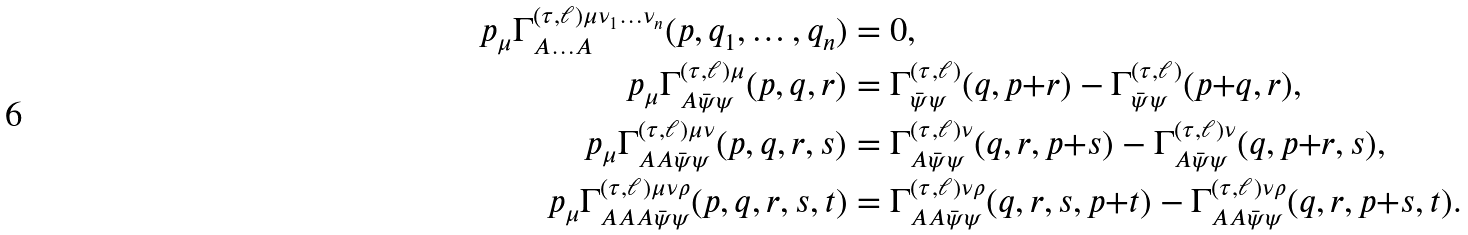Convert formula to latex. <formula><loc_0><loc_0><loc_500><loc_500>p _ { \mu } \Gamma ^ { ( \tau , \ell ) \mu \nu _ { 1 } \dots \nu _ { n } } _ { A \dots A } ( p , q _ { 1 } , \dots , q _ { n } ) & = 0 , \\ p _ { \mu } \Gamma ^ { ( \tau , \ell ) \mu } _ { A \bar { \psi } \psi } ( p , q , r ) & = \Gamma ^ { ( \tau , \ell ) } _ { \bar { \psi } \psi } ( q , p { + } r ) - \Gamma ^ { ( \tau , \ell ) } _ { \bar { \psi } \psi } ( p { + } q , r ) , \\ p _ { \mu } \Gamma ^ { ( \tau , \ell ) \mu \nu } _ { A A \bar { \psi } \psi } ( p , q , r , s ) & = \Gamma ^ { ( \tau , \ell ) \nu } _ { A \bar { \psi } \psi } ( q , r , p { + } s ) - \Gamma ^ { ( \tau , \ell ) \nu } _ { A \bar { \psi } \psi } ( q , p { + } r , s ) , \\ p _ { \mu } \Gamma ^ { ( \tau , \ell ) \mu \nu \rho } _ { A A A \bar { \psi } \psi } ( p , q , r , s , t ) & = \Gamma ^ { ( \tau , \ell ) \nu \rho } _ { A A \bar { \psi } \psi } ( q , r , s , p { + } t ) - \Gamma ^ { ( \tau , \ell ) \nu \rho } _ { A A \bar { \psi } \psi } ( q , r , p { + } s , t ) .</formula> 